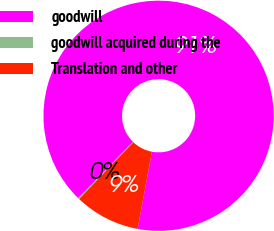Convert chart. <chart><loc_0><loc_0><loc_500><loc_500><pie_chart><fcel>goodwill<fcel>goodwill acquired during the<fcel>Translation and other<nl><fcel>90.62%<fcel>0.17%<fcel>9.21%<nl></chart> 